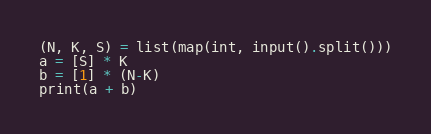<code> <loc_0><loc_0><loc_500><loc_500><_Python_>(N, K, S) = list(map(int, input().split()))
a = [S] * K
b = [1] * (N-K)
print(a + b)
</code> 